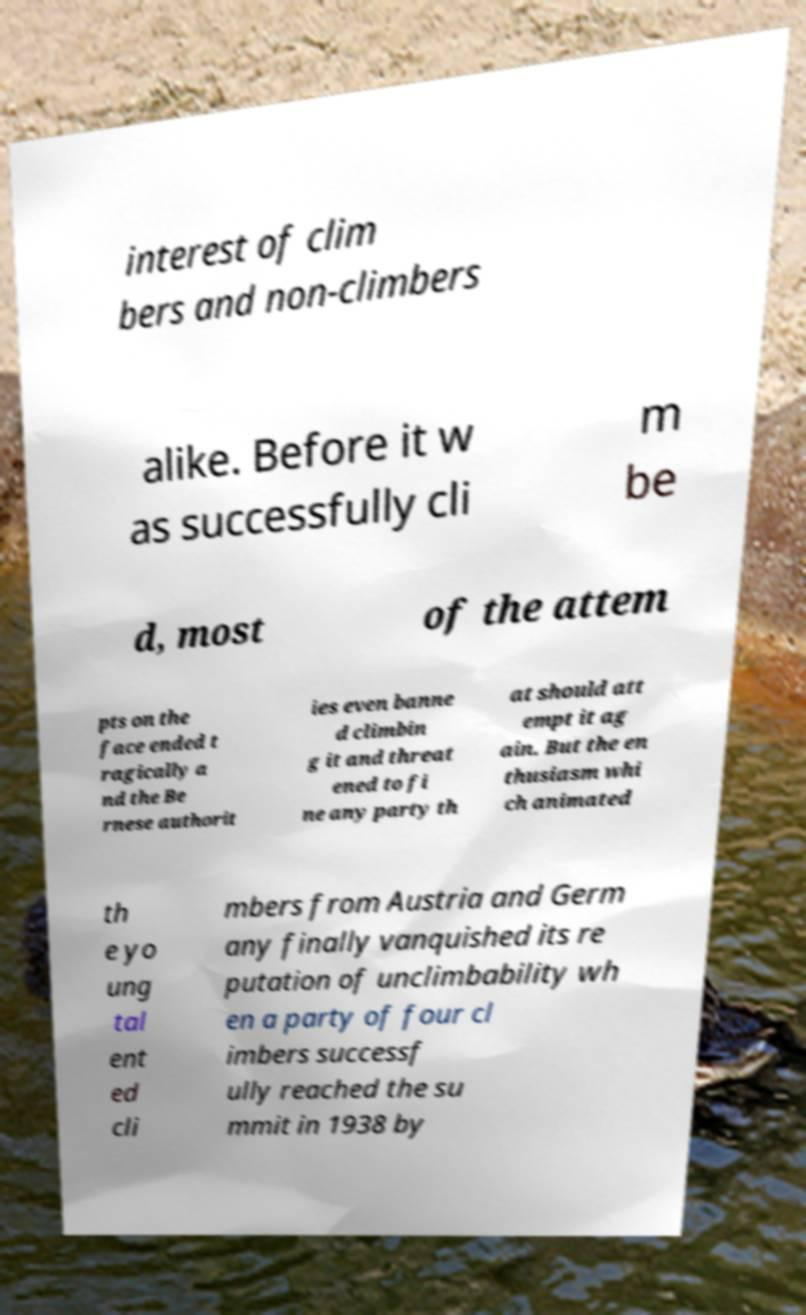Please read and relay the text visible in this image. What does it say? interest of clim bers and non-climbers alike. Before it w as successfully cli m be d, most of the attem pts on the face ended t ragically a nd the Be rnese authorit ies even banne d climbin g it and threat ened to fi ne any party th at should att empt it ag ain. But the en thusiasm whi ch animated th e yo ung tal ent ed cli mbers from Austria and Germ any finally vanquished its re putation of unclimbability wh en a party of four cl imbers successf ully reached the su mmit in 1938 by 